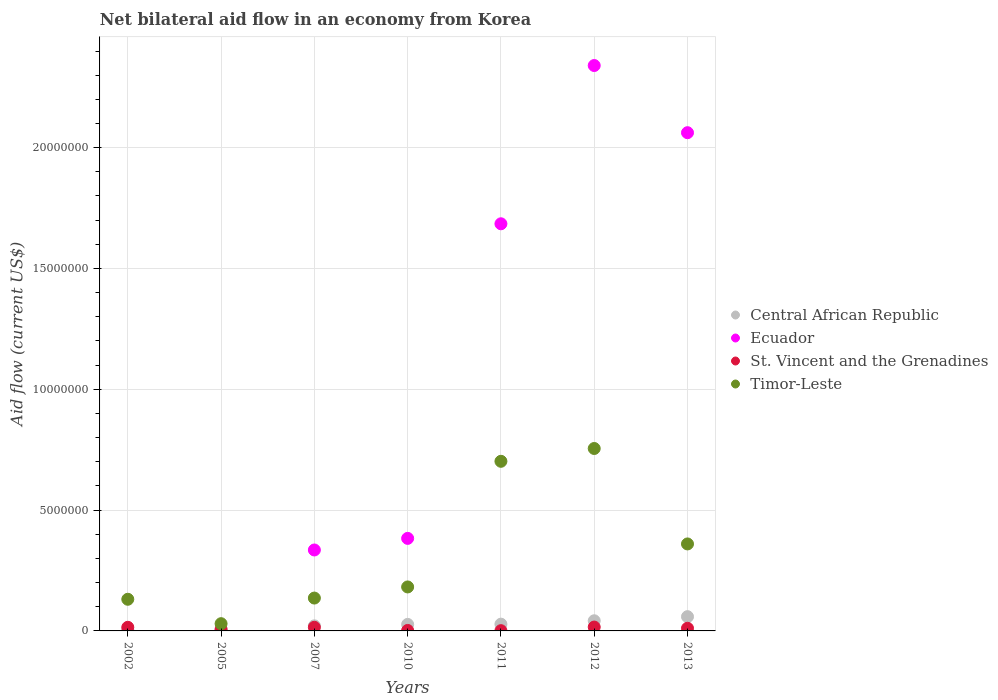How many different coloured dotlines are there?
Offer a terse response. 4. Is the number of dotlines equal to the number of legend labels?
Make the answer very short. No. Across all years, what is the maximum net bilateral aid flow in Ecuador?
Offer a very short reply. 2.34e+07. Across all years, what is the minimum net bilateral aid flow in Timor-Leste?
Ensure brevity in your answer.  3.00e+05. What is the total net bilateral aid flow in Ecuador in the graph?
Your answer should be compact. 6.80e+07. What is the difference between the net bilateral aid flow in Central African Republic in 2005 and that in 2013?
Offer a terse response. -5.20e+05. What is the difference between the net bilateral aid flow in Central African Republic in 2013 and the net bilateral aid flow in St. Vincent and the Grenadines in 2012?
Provide a short and direct response. 4.30e+05. What is the average net bilateral aid flow in Timor-Leste per year?
Your response must be concise. 3.28e+06. In the year 2010, what is the difference between the net bilateral aid flow in Central African Republic and net bilateral aid flow in Timor-Leste?
Your response must be concise. -1.55e+06. What is the ratio of the net bilateral aid flow in Central African Republic in 2005 to that in 2011?
Your answer should be very brief. 0.25. Is the difference between the net bilateral aid flow in Central African Republic in 2007 and 2012 greater than the difference between the net bilateral aid flow in Timor-Leste in 2007 and 2012?
Provide a short and direct response. Yes. What is the difference between the highest and the second highest net bilateral aid flow in Timor-Leste?
Offer a very short reply. 5.30e+05. What is the difference between the highest and the lowest net bilateral aid flow in Central African Republic?
Offer a very short reply. 5.40e+05. Does the net bilateral aid flow in St. Vincent and the Grenadines monotonically increase over the years?
Your answer should be very brief. No. Is the net bilateral aid flow in Central African Republic strictly greater than the net bilateral aid flow in St. Vincent and the Grenadines over the years?
Offer a very short reply. No. Is the net bilateral aid flow in Ecuador strictly less than the net bilateral aid flow in St. Vincent and the Grenadines over the years?
Give a very brief answer. No. How many years are there in the graph?
Provide a short and direct response. 7. Does the graph contain grids?
Offer a very short reply. Yes. What is the title of the graph?
Provide a succinct answer. Net bilateral aid flow in an economy from Korea. Does "Hungary" appear as one of the legend labels in the graph?
Keep it short and to the point. No. What is the label or title of the X-axis?
Your answer should be compact. Years. What is the Aid flow (current US$) of Central African Republic in 2002?
Your answer should be compact. 5.00e+04. What is the Aid flow (current US$) of Ecuador in 2002?
Provide a succinct answer. 0. What is the Aid flow (current US$) in St. Vincent and the Grenadines in 2002?
Offer a very short reply. 1.50e+05. What is the Aid flow (current US$) of Timor-Leste in 2002?
Give a very brief answer. 1.31e+06. What is the Aid flow (current US$) of Central African Republic in 2005?
Your answer should be compact. 7.00e+04. What is the Aid flow (current US$) in St. Vincent and the Grenadines in 2005?
Offer a terse response. 6.00e+04. What is the Aid flow (current US$) of Timor-Leste in 2005?
Offer a terse response. 3.00e+05. What is the Aid flow (current US$) of Ecuador in 2007?
Give a very brief answer. 3.35e+06. What is the Aid flow (current US$) in St. Vincent and the Grenadines in 2007?
Keep it short and to the point. 1.50e+05. What is the Aid flow (current US$) of Timor-Leste in 2007?
Make the answer very short. 1.36e+06. What is the Aid flow (current US$) of Central African Republic in 2010?
Offer a terse response. 2.70e+05. What is the Aid flow (current US$) of Ecuador in 2010?
Provide a short and direct response. 3.83e+06. What is the Aid flow (current US$) in Timor-Leste in 2010?
Your answer should be compact. 1.82e+06. What is the Aid flow (current US$) in Ecuador in 2011?
Ensure brevity in your answer.  1.68e+07. What is the Aid flow (current US$) in Timor-Leste in 2011?
Give a very brief answer. 7.02e+06. What is the Aid flow (current US$) of Central African Republic in 2012?
Provide a succinct answer. 4.20e+05. What is the Aid flow (current US$) of Ecuador in 2012?
Offer a very short reply. 2.34e+07. What is the Aid flow (current US$) in Timor-Leste in 2012?
Provide a succinct answer. 7.55e+06. What is the Aid flow (current US$) in Central African Republic in 2013?
Provide a short and direct response. 5.90e+05. What is the Aid flow (current US$) in Ecuador in 2013?
Offer a very short reply. 2.06e+07. What is the Aid flow (current US$) of Timor-Leste in 2013?
Offer a very short reply. 3.60e+06. Across all years, what is the maximum Aid flow (current US$) in Central African Republic?
Ensure brevity in your answer.  5.90e+05. Across all years, what is the maximum Aid flow (current US$) of Ecuador?
Your response must be concise. 2.34e+07. Across all years, what is the maximum Aid flow (current US$) of Timor-Leste?
Your answer should be very brief. 7.55e+06. Across all years, what is the minimum Aid flow (current US$) of Ecuador?
Give a very brief answer. 0. Across all years, what is the minimum Aid flow (current US$) of St. Vincent and the Grenadines?
Provide a succinct answer. 10000. Across all years, what is the minimum Aid flow (current US$) of Timor-Leste?
Your response must be concise. 3.00e+05. What is the total Aid flow (current US$) of Central African Republic in the graph?
Keep it short and to the point. 1.89e+06. What is the total Aid flow (current US$) in Ecuador in the graph?
Your response must be concise. 6.80e+07. What is the total Aid flow (current US$) of St. Vincent and the Grenadines in the graph?
Keep it short and to the point. 6.60e+05. What is the total Aid flow (current US$) in Timor-Leste in the graph?
Offer a very short reply. 2.30e+07. What is the difference between the Aid flow (current US$) in Central African Republic in 2002 and that in 2005?
Your response must be concise. -2.00e+04. What is the difference between the Aid flow (current US$) of Timor-Leste in 2002 and that in 2005?
Ensure brevity in your answer.  1.01e+06. What is the difference between the Aid flow (current US$) in Central African Republic in 2002 and that in 2007?
Keep it short and to the point. -1.60e+05. What is the difference between the Aid flow (current US$) of Central African Republic in 2002 and that in 2010?
Your answer should be compact. -2.20e+05. What is the difference between the Aid flow (current US$) of St. Vincent and the Grenadines in 2002 and that in 2010?
Your response must be concise. 1.30e+05. What is the difference between the Aid flow (current US$) in Timor-Leste in 2002 and that in 2010?
Offer a terse response. -5.10e+05. What is the difference between the Aid flow (current US$) in Timor-Leste in 2002 and that in 2011?
Provide a short and direct response. -5.71e+06. What is the difference between the Aid flow (current US$) in Central African Republic in 2002 and that in 2012?
Keep it short and to the point. -3.70e+05. What is the difference between the Aid flow (current US$) in Timor-Leste in 2002 and that in 2012?
Give a very brief answer. -6.24e+06. What is the difference between the Aid flow (current US$) of Central African Republic in 2002 and that in 2013?
Your answer should be very brief. -5.40e+05. What is the difference between the Aid flow (current US$) of Timor-Leste in 2002 and that in 2013?
Make the answer very short. -2.29e+06. What is the difference between the Aid flow (current US$) in St. Vincent and the Grenadines in 2005 and that in 2007?
Your answer should be very brief. -9.00e+04. What is the difference between the Aid flow (current US$) in Timor-Leste in 2005 and that in 2007?
Your answer should be very brief. -1.06e+06. What is the difference between the Aid flow (current US$) in St. Vincent and the Grenadines in 2005 and that in 2010?
Your answer should be compact. 4.00e+04. What is the difference between the Aid flow (current US$) of Timor-Leste in 2005 and that in 2010?
Your response must be concise. -1.52e+06. What is the difference between the Aid flow (current US$) in Central African Republic in 2005 and that in 2011?
Your answer should be very brief. -2.10e+05. What is the difference between the Aid flow (current US$) of Timor-Leste in 2005 and that in 2011?
Your answer should be very brief. -6.72e+06. What is the difference between the Aid flow (current US$) of Central African Republic in 2005 and that in 2012?
Your answer should be very brief. -3.50e+05. What is the difference between the Aid flow (current US$) in St. Vincent and the Grenadines in 2005 and that in 2012?
Your answer should be compact. -1.00e+05. What is the difference between the Aid flow (current US$) of Timor-Leste in 2005 and that in 2012?
Make the answer very short. -7.25e+06. What is the difference between the Aid flow (current US$) of Central African Republic in 2005 and that in 2013?
Offer a terse response. -5.20e+05. What is the difference between the Aid flow (current US$) in St. Vincent and the Grenadines in 2005 and that in 2013?
Make the answer very short. -5.00e+04. What is the difference between the Aid flow (current US$) in Timor-Leste in 2005 and that in 2013?
Give a very brief answer. -3.30e+06. What is the difference between the Aid flow (current US$) of Ecuador in 2007 and that in 2010?
Keep it short and to the point. -4.80e+05. What is the difference between the Aid flow (current US$) in St. Vincent and the Grenadines in 2007 and that in 2010?
Give a very brief answer. 1.30e+05. What is the difference between the Aid flow (current US$) in Timor-Leste in 2007 and that in 2010?
Give a very brief answer. -4.60e+05. What is the difference between the Aid flow (current US$) in Central African Republic in 2007 and that in 2011?
Keep it short and to the point. -7.00e+04. What is the difference between the Aid flow (current US$) of Ecuador in 2007 and that in 2011?
Keep it short and to the point. -1.35e+07. What is the difference between the Aid flow (current US$) in Timor-Leste in 2007 and that in 2011?
Your answer should be compact. -5.66e+06. What is the difference between the Aid flow (current US$) in Ecuador in 2007 and that in 2012?
Ensure brevity in your answer.  -2.00e+07. What is the difference between the Aid flow (current US$) in Timor-Leste in 2007 and that in 2012?
Your answer should be very brief. -6.19e+06. What is the difference between the Aid flow (current US$) in Central African Republic in 2007 and that in 2013?
Give a very brief answer. -3.80e+05. What is the difference between the Aid flow (current US$) of Ecuador in 2007 and that in 2013?
Offer a terse response. -1.73e+07. What is the difference between the Aid flow (current US$) of St. Vincent and the Grenadines in 2007 and that in 2013?
Offer a terse response. 4.00e+04. What is the difference between the Aid flow (current US$) of Timor-Leste in 2007 and that in 2013?
Keep it short and to the point. -2.24e+06. What is the difference between the Aid flow (current US$) of Central African Republic in 2010 and that in 2011?
Offer a terse response. -10000. What is the difference between the Aid flow (current US$) of Ecuador in 2010 and that in 2011?
Provide a succinct answer. -1.30e+07. What is the difference between the Aid flow (current US$) of Timor-Leste in 2010 and that in 2011?
Offer a very short reply. -5.20e+06. What is the difference between the Aid flow (current US$) in Ecuador in 2010 and that in 2012?
Your response must be concise. -1.96e+07. What is the difference between the Aid flow (current US$) of St. Vincent and the Grenadines in 2010 and that in 2012?
Provide a succinct answer. -1.40e+05. What is the difference between the Aid flow (current US$) of Timor-Leste in 2010 and that in 2012?
Offer a terse response. -5.73e+06. What is the difference between the Aid flow (current US$) in Central African Republic in 2010 and that in 2013?
Ensure brevity in your answer.  -3.20e+05. What is the difference between the Aid flow (current US$) in Ecuador in 2010 and that in 2013?
Provide a short and direct response. -1.68e+07. What is the difference between the Aid flow (current US$) of St. Vincent and the Grenadines in 2010 and that in 2013?
Provide a succinct answer. -9.00e+04. What is the difference between the Aid flow (current US$) of Timor-Leste in 2010 and that in 2013?
Offer a very short reply. -1.78e+06. What is the difference between the Aid flow (current US$) in Ecuador in 2011 and that in 2012?
Your answer should be compact. -6.55e+06. What is the difference between the Aid flow (current US$) in Timor-Leste in 2011 and that in 2012?
Offer a very short reply. -5.30e+05. What is the difference between the Aid flow (current US$) of Central African Republic in 2011 and that in 2013?
Your answer should be very brief. -3.10e+05. What is the difference between the Aid flow (current US$) of Ecuador in 2011 and that in 2013?
Give a very brief answer. -3.77e+06. What is the difference between the Aid flow (current US$) of St. Vincent and the Grenadines in 2011 and that in 2013?
Give a very brief answer. -1.00e+05. What is the difference between the Aid flow (current US$) of Timor-Leste in 2011 and that in 2013?
Your response must be concise. 3.42e+06. What is the difference between the Aid flow (current US$) in Central African Republic in 2012 and that in 2013?
Make the answer very short. -1.70e+05. What is the difference between the Aid flow (current US$) of Ecuador in 2012 and that in 2013?
Offer a terse response. 2.78e+06. What is the difference between the Aid flow (current US$) of Timor-Leste in 2012 and that in 2013?
Your answer should be compact. 3.95e+06. What is the difference between the Aid flow (current US$) of Central African Republic in 2002 and the Aid flow (current US$) of St. Vincent and the Grenadines in 2005?
Your answer should be compact. -10000. What is the difference between the Aid flow (current US$) of Central African Republic in 2002 and the Aid flow (current US$) of Timor-Leste in 2005?
Make the answer very short. -2.50e+05. What is the difference between the Aid flow (current US$) in St. Vincent and the Grenadines in 2002 and the Aid flow (current US$) in Timor-Leste in 2005?
Ensure brevity in your answer.  -1.50e+05. What is the difference between the Aid flow (current US$) of Central African Republic in 2002 and the Aid flow (current US$) of Ecuador in 2007?
Give a very brief answer. -3.30e+06. What is the difference between the Aid flow (current US$) in Central African Republic in 2002 and the Aid flow (current US$) in St. Vincent and the Grenadines in 2007?
Give a very brief answer. -1.00e+05. What is the difference between the Aid flow (current US$) of Central African Republic in 2002 and the Aid flow (current US$) of Timor-Leste in 2007?
Offer a very short reply. -1.31e+06. What is the difference between the Aid flow (current US$) in St. Vincent and the Grenadines in 2002 and the Aid flow (current US$) in Timor-Leste in 2007?
Your answer should be compact. -1.21e+06. What is the difference between the Aid flow (current US$) in Central African Republic in 2002 and the Aid flow (current US$) in Ecuador in 2010?
Give a very brief answer. -3.78e+06. What is the difference between the Aid flow (current US$) in Central African Republic in 2002 and the Aid flow (current US$) in Timor-Leste in 2010?
Keep it short and to the point. -1.77e+06. What is the difference between the Aid flow (current US$) of St. Vincent and the Grenadines in 2002 and the Aid flow (current US$) of Timor-Leste in 2010?
Give a very brief answer. -1.67e+06. What is the difference between the Aid flow (current US$) of Central African Republic in 2002 and the Aid flow (current US$) of Ecuador in 2011?
Your answer should be very brief. -1.68e+07. What is the difference between the Aid flow (current US$) of Central African Republic in 2002 and the Aid flow (current US$) of St. Vincent and the Grenadines in 2011?
Offer a very short reply. 4.00e+04. What is the difference between the Aid flow (current US$) of Central African Republic in 2002 and the Aid flow (current US$) of Timor-Leste in 2011?
Your answer should be compact. -6.97e+06. What is the difference between the Aid flow (current US$) in St. Vincent and the Grenadines in 2002 and the Aid flow (current US$) in Timor-Leste in 2011?
Provide a succinct answer. -6.87e+06. What is the difference between the Aid flow (current US$) of Central African Republic in 2002 and the Aid flow (current US$) of Ecuador in 2012?
Offer a very short reply. -2.34e+07. What is the difference between the Aid flow (current US$) in Central African Republic in 2002 and the Aid flow (current US$) in St. Vincent and the Grenadines in 2012?
Keep it short and to the point. -1.10e+05. What is the difference between the Aid flow (current US$) in Central African Republic in 2002 and the Aid flow (current US$) in Timor-Leste in 2012?
Provide a short and direct response. -7.50e+06. What is the difference between the Aid flow (current US$) of St. Vincent and the Grenadines in 2002 and the Aid flow (current US$) of Timor-Leste in 2012?
Your response must be concise. -7.40e+06. What is the difference between the Aid flow (current US$) in Central African Republic in 2002 and the Aid flow (current US$) in Ecuador in 2013?
Provide a succinct answer. -2.06e+07. What is the difference between the Aid flow (current US$) in Central African Republic in 2002 and the Aid flow (current US$) in Timor-Leste in 2013?
Offer a very short reply. -3.55e+06. What is the difference between the Aid flow (current US$) of St. Vincent and the Grenadines in 2002 and the Aid flow (current US$) of Timor-Leste in 2013?
Your answer should be very brief. -3.45e+06. What is the difference between the Aid flow (current US$) in Central African Republic in 2005 and the Aid flow (current US$) in Ecuador in 2007?
Offer a terse response. -3.28e+06. What is the difference between the Aid flow (current US$) in Central African Republic in 2005 and the Aid flow (current US$) in St. Vincent and the Grenadines in 2007?
Give a very brief answer. -8.00e+04. What is the difference between the Aid flow (current US$) of Central African Republic in 2005 and the Aid flow (current US$) of Timor-Leste in 2007?
Keep it short and to the point. -1.29e+06. What is the difference between the Aid flow (current US$) in St. Vincent and the Grenadines in 2005 and the Aid flow (current US$) in Timor-Leste in 2007?
Provide a short and direct response. -1.30e+06. What is the difference between the Aid flow (current US$) in Central African Republic in 2005 and the Aid flow (current US$) in Ecuador in 2010?
Make the answer very short. -3.76e+06. What is the difference between the Aid flow (current US$) in Central African Republic in 2005 and the Aid flow (current US$) in St. Vincent and the Grenadines in 2010?
Ensure brevity in your answer.  5.00e+04. What is the difference between the Aid flow (current US$) of Central African Republic in 2005 and the Aid flow (current US$) of Timor-Leste in 2010?
Make the answer very short. -1.75e+06. What is the difference between the Aid flow (current US$) in St. Vincent and the Grenadines in 2005 and the Aid flow (current US$) in Timor-Leste in 2010?
Provide a short and direct response. -1.76e+06. What is the difference between the Aid flow (current US$) in Central African Republic in 2005 and the Aid flow (current US$) in Ecuador in 2011?
Your answer should be compact. -1.68e+07. What is the difference between the Aid flow (current US$) of Central African Republic in 2005 and the Aid flow (current US$) of St. Vincent and the Grenadines in 2011?
Keep it short and to the point. 6.00e+04. What is the difference between the Aid flow (current US$) in Central African Republic in 2005 and the Aid flow (current US$) in Timor-Leste in 2011?
Your answer should be very brief. -6.95e+06. What is the difference between the Aid flow (current US$) in St. Vincent and the Grenadines in 2005 and the Aid flow (current US$) in Timor-Leste in 2011?
Your response must be concise. -6.96e+06. What is the difference between the Aid flow (current US$) of Central African Republic in 2005 and the Aid flow (current US$) of Ecuador in 2012?
Your answer should be very brief. -2.33e+07. What is the difference between the Aid flow (current US$) of Central African Republic in 2005 and the Aid flow (current US$) of St. Vincent and the Grenadines in 2012?
Your answer should be very brief. -9.00e+04. What is the difference between the Aid flow (current US$) of Central African Republic in 2005 and the Aid flow (current US$) of Timor-Leste in 2012?
Ensure brevity in your answer.  -7.48e+06. What is the difference between the Aid flow (current US$) of St. Vincent and the Grenadines in 2005 and the Aid flow (current US$) of Timor-Leste in 2012?
Offer a terse response. -7.49e+06. What is the difference between the Aid flow (current US$) of Central African Republic in 2005 and the Aid flow (current US$) of Ecuador in 2013?
Provide a succinct answer. -2.06e+07. What is the difference between the Aid flow (current US$) of Central African Republic in 2005 and the Aid flow (current US$) of Timor-Leste in 2013?
Give a very brief answer. -3.53e+06. What is the difference between the Aid flow (current US$) in St. Vincent and the Grenadines in 2005 and the Aid flow (current US$) in Timor-Leste in 2013?
Offer a very short reply. -3.54e+06. What is the difference between the Aid flow (current US$) of Central African Republic in 2007 and the Aid flow (current US$) of Ecuador in 2010?
Offer a terse response. -3.62e+06. What is the difference between the Aid flow (current US$) of Central African Republic in 2007 and the Aid flow (current US$) of Timor-Leste in 2010?
Your answer should be compact. -1.61e+06. What is the difference between the Aid flow (current US$) in Ecuador in 2007 and the Aid flow (current US$) in St. Vincent and the Grenadines in 2010?
Ensure brevity in your answer.  3.33e+06. What is the difference between the Aid flow (current US$) in Ecuador in 2007 and the Aid flow (current US$) in Timor-Leste in 2010?
Provide a succinct answer. 1.53e+06. What is the difference between the Aid flow (current US$) in St. Vincent and the Grenadines in 2007 and the Aid flow (current US$) in Timor-Leste in 2010?
Keep it short and to the point. -1.67e+06. What is the difference between the Aid flow (current US$) of Central African Republic in 2007 and the Aid flow (current US$) of Ecuador in 2011?
Provide a short and direct response. -1.66e+07. What is the difference between the Aid flow (current US$) in Central African Republic in 2007 and the Aid flow (current US$) in Timor-Leste in 2011?
Make the answer very short. -6.81e+06. What is the difference between the Aid flow (current US$) in Ecuador in 2007 and the Aid flow (current US$) in St. Vincent and the Grenadines in 2011?
Offer a terse response. 3.34e+06. What is the difference between the Aid flow (current US$) of Ecuador in 2007 and the Aid flow (current US$) of Timor-Leste in 2011?
Provide a succinct answer. -3.67e+06. What is the difference between the Aid flow (current US$) in St. Vincent and the Grenadines in 2007 and the Aid flow (current US$) in Timor-Leste in 2011?
Keep it short and to the point. -6.87e+06. What is the difference between the Aid flow (current US$) in Central African Republic in 2007 and the Aid flow (current US$) in Ecuador in 2012?
Offer a terse response. -2.32e+07. What is the difference between the Aid flow (current US$) of Central African Republic in 2007 and the Aid flow (current US$) of Timor-Leste in 2012?
Offer a terse response. -7.34e+06. What is the difference between the Aid flow (current US$) in Ecuador in 2007 and the Aid flow (current US$) in St. Vincent and the Grenadines in 2012?
Provide a succinct answer. 3.19e+06. What is the difference between the Aid flow (current US$) of Ecuador in 2007 and the Aid flow (current US$) of Timor-Leste in 2012?
Your answer should be very brief. -4.20e+06. What is the difference between the Aid flow (current US$) in St. Vincent and the Grenadines in 2007 and the Aid flow (current US$) in Timor-Leste in 2012?
Keep it short and to the point. -7.40e+06. What is the difference between the Aid flow (current US$) in Central African Republic in 2007 and the Aid flow (current US$) in Ecuador in 2013?
Your answer should be very brief. -2.04e+07. What is the difference between the Aid flow (current US$) of Central African Republic in 2007 and the Aid flow (current US$) of St. Vincent and the Grenadines in 2013?
Make the answer very short. 1.00e+05. What is the difference between the Aid flow (current US$) in Central African Republic in 2007 and the Aid flow (current US$) in Timor-Leste in 2013?
Provide a short and direct response. -3.39e+06. What is the difference between the Aid flow (current US$) of Ecuador in 2007 and the Aid flow (current US$) of St. Vincent and the Grenadines in 2013?
Keep it short and to the point. 3.24e+06. What is the difference between the Aid flow (current US$) of St. Vincent and the Grenadines in 2007 and the Aid flow (current US$) of Timor-Leste in 2013?
Provide a short and direct response. -3.45e+06. What is the difference between the Aid flow (current US$) of Central African Republic in 2010 and the Aid flow (current US$) of Ecuador in 2011?
Give a very brief answer. -1.66e+07. What is the difference between the Aid flow (current US$) of Central African Republic in 2010 and the Aid flow (current US$) of St. Vincent and the Grenadines in 2011?
Offer a very short reply. 2.60e+05. What is the difference between the Aid flow (current US$) in Central African Republic in 2010 and the Aid flow (current US$) in Timor-Leste in 2011?
Your answer should be very brief. -6.75e+06. What is the difference between the Aid flow (current US$) of Ecuador in 2010 and the Aid flow (current US$) of St. Vincent and the Grenadines in 2011?
Ensure brevity in your answer.  3.82e+06. What is the difference between the Aid flow (current US$) in Ecuador in 2010 and the Aid flow (current US$) in Timor-Leste in 2011?
Your answer should be very brief. -3.19e+06. What is the difference between the Aid flow (current US$) of St. Vincent and the Grenadines in 2010 and the Aid flow (current US$) of Timor-Leste in 2011?
Your answer should be compact. -7.00e+06. What is the difference between the Aid flow (current US$) of Central African Republic in 2010 and the Aid flow (current US$) of Ecuador in 2012?
Provide a short and direct response. -2.31e+07. What is the difference between the Aid flow (current US$) in Central African Republic in 2010 and the Aid flow (current US$) in Timor-Leste in 2012?
Your answer should be compact. -7.28e+06. What is the difference between the Aid flow (current US$) in Ecuador in 2010 and the Aid flow (current US$) in St. Vincent and the Grenadines in 2012?
Provide a short and direct response. 3.67e+06. What is the difference between the Aid flow (current US$) in Ecuador in 2010 and the Aid flow (current US$) in Timor-Leste in 2012?
Offer a very short reply. -3.72e+06. What is the difference between the Aid flow (current US$) in St. Vincent and the Grenadines in 2010 and the Aid flow (current US$) in Timor-Leste in 2012?
Provide a succinct answer. -7.53e+06. What is the difference between the Aid flow (current US$) of Central African Republic in 2010 and the Aid flow (current US$) of Ecuador in 2013?
Offer a terse response. -2.04e+07. What is the difference between the Aid flow (current US$) of Central African Republic in 2010 and the Aid flow (current US$) of St. Vincent and the Grenadines in 2013?
Your response must be concise. 1.60e+05. What is the difference between the Aid flow (current US$) of Central African Republic in 2010 and the Aid flow (current US$) of Timor-Leste in 2013?
Give a very brief answer. -3.33e+06. What is the difference between the Aid flow (current US$) in Ecuador in 2010 and the Aid flow (current US$) in St. Vincent and the Grenadines in 2013?
Ensure brevity in your answer.  3.72e+06. What is the difference between the Aid flow (current US$) in St. Vincent and the Grenadines in 2010 and the Aid flow (current US$) in Timor-Leste in 2013?
Offer a very short reply. -3.58e+06. What is the difference between the Aid flow (current US$) in Central African Republic in 2011 and the Aid flow (current US$) in Ecuador in 2012?
Ensure brevity in your answer.  -2.31e+07. What is the difference between the Aid flow (current US$) in Central African Republic in 2011 and the Aid flow (current US$) in St. Vincent and the Grenadines in 2012?
Provide a short and direct response. 1.20e+05. What is the difference between the Aid flow (current US$) in Central African Republic in 2011 and the Aid flow (current US$) in Timor-Leste in 2012?
Your answer should be very brief. -7.27e+06. What is the difference between the Aid flow (current US$) in Ecuador in 2011 and the Aid flow (current US$) in St. Vincent and the Grenadines in 2012?
Give a very brief answer. 1.67e+07. What is the difference between the Aid flow (current US$) in Ecuador in 2011 and the Aid flow (current US$) in Timor-Leste in 2012?
Your answer should be very brief. 9.30e+06. What is the difference between the Aid flow (current US$) of St. Vincent and the Grenadines in 2011 and the Aid flow (current US$) of Timor-Leste in 2012?
Provide a succinct answer. -7.54e+06. What is the difference between the Aid flow (current US$) of Central African Republic in 2011 and the Aid flow (current US$) of Ecuador in 2013?
Ensure brevity in your answer.  -2.03e+07. What is the difference between the Aid flow (current US$) in Central African Republic in 2011 and the Aid flow (current US$) in St. Vincent and the Grenadines in 2013?
Provide a short and direct response. 1.70e+05. What is the difference between the Aid flow (current US$) of Central African Republic in 2011 and the Aid flow (current US$) of Timor-Leste in 2013?
Your answer should be compact. -3.32e+06. What is the difference between the Aid flow (current US$) of Ecuador in 2011 and the Aid flow (current US$) of St. Vincent and the Grenadines in 2013?
Make the answer very short. 1.67e+07. What is the difference between the Aid flow (current US$) in Ecuador in 2011 and the Aid flow (current US$) in Timor-Leste in 2013?
Keep it short and to the point. 1.32e+07. What is the difference between the Aid flow (current US$) in St. Vincent and the Grenadines in 2011 and the Aid flow (current US$) in Timor-Leste in 2013?
Ensure brevity in your answer.  -3.59e+06. What is the difference between the Aid flow (current US$) of Central African Republic in 2012 and the Aid flow (current US$) of Ecuador in 2013?
Ensure brevity in your answer.  -2.02e+07. What is the difference between the Aid flow (current US$) of Central African Republic in 2012 and the Aid flow (current US$) of Timor-Leste in 2013?
Your answer should be very brief. -3.18e+06. What is the difference between the Aid flow (current US$) in Ecuador in 2012 and the Aid flow (current US$) in St. Vincent and the Grenadines in 2013?
Your response must be concise. 2.33e+07. What is the difference between the Aid flow (current US$) in Ecuador in 2012 and the Aid flow (current US$) in Timor-Leste in 2013?
Your response must be concise. 1.98e+07. What is the difference between the Aid flow (current US$) of St. Vincent and the Grenadines in 2012 and the Aid flow (current US$) of Timor-Leste in 2013?
Give a very brief answer. -3.44e+06. What is the average Aid flow (current US$) in Ecuador per year?
Provide a short and direct response. 9.72e+06. What is the average Aid flow (current US$) of St. Vincent and the Grenadines per year?
Ensure brevity in your answer.  9.43e+04. What is the average Aid flow (current US$) of Timor-Leste per year?
Keep it short and to the point. 3.28e+06. In the year 2002, what is the difference between the Aid flow (current US$) in Central African Republic and Aid flow (current US$) in St. Vincent and the Grenadines?
Make the answer very short. -1.00e+05. In the year 2002, what is the difference between the Aid flow (current US$) of Central African Republic and Aid flow (current US$) of Timor-Leste?
Make the answer very short. -1.26e+06. In the year 2002, what is the difference between the Aid flow (current US$) of St. Vincent and the Grenadines and Aid flow (current US$) of Timor-Leste?
Provide a succinct answer. -1.16e+06. In the year 2007, what is the difference between the Aid flow (current US$) in Central African Republic and Aid flow (current US$) in Ecuador?
Offer a terse response. -3.14e+06. In the year 2007, what is the difference between the Aid flow (current US$) of Central African Republic and Aid flow (current US$) of Timor-Leste?
Make the answer very short. -1.15e+06. In the year 2007, what is the difference between the Aid flow (current US$) of Ecuador and Aid flow (current US$) of St. Vincent and the Grenadines?
Your answer should be compact. 3.20e+06. In the year 2007, what is the difference between the Aid flow (current US$) of Ecuador and Aid flow (current US$) of Timor-Leste?
Keep it short and to the point. 1.99e+06. In the year 2007, what is the difference between the Aid flow (current US$) of St. Vincent and the Grenadines and Aid flow (current US$) of Timor-Leste?
Give a very brief answer. -1.21e+06. In the year 2010, what is the difference between the Aid flow (current US$) in Central African Republic and Aid flow (current US$) in Ecuador?
Provide a succinct answer. -3.56e+06. In the year 2010, what is the difference between the Aid flow (current US$) of Central African Republic and Aid flow (current US$) of St. Vincent and the Grenadines?
Your answer should be very brief. 2.50e+05. In the year 2010, what is the difference between the Aid flow (current US$) in Central African Republic and Aid flow (current US$) in Timor-Leste?
Your answer should be very brief. -1.55e+06. In the year 2010, what is the difference between the Aid flow (current US$) of Ecuador and Aid flow (current US$) of St. Vincent and the Grenadines?
Provide a short and direct response. 3.81e+06. In the year 2010, what is the difference between the Aid flow (current US$) of Ecuador and Aid flow (current US$) of Timor-Leste?
Your answer should be compact. 2.01e+06. In the year 2010, what is the difference between the Aid flow (current US$) in St. Vincent and the Grenadines and Aid flow (current US$) in Timor-Leste?
Offer a terse response. -1.80e+06. In the year 2011, what is the difference between the Aid flow (current US$) in Central African Republic and Aid flow (current US$) in Ecuador?
Offer a very short reply. -1.66e+07. In the year 2011, what is the difference between the Aid flow (current US$) of Central African Republic and Aid flow (current US$) of St. Vincent and the Grenadines?
Keep it short and to the point. 2.70e+05. In the year 2011, what is the difference between the Aid flow (current US$) of Central African Republic and Aid flow (current US$) of Timor-Leste?
Give a very brief answer. -6.74e+06. In the year 2011, what is the difference between the Aid flow (current US$) of Ecuador and Aid flow (current US$) of St. Vincent and the Grenadines?
Offer a terse response. 1.68e+07. In the year 2011, what is the difference between the Aid flow (current US$) of Ecuador and Aid flow (current US$) of Timor-Leste?
Ensure brevity in your answer.  9.83e+06. In the year 2011, what is the difference between the Aid flow (current US$) of St. Vincent and the Grenadines and Aid flow (current US$) of Timor-Leste?
Offer a very short reply. -7.01e+06. In the year 2012, what is the difference between the Aid flow (current US$) in Central African Republic and Aid flow (current US$) in Ecuador?
Give a very brief answer. -2.30e+07. In the year 2012, what is the difference between the Aid flow (current US$) of Central African Republic and Aid flow (current US$) of Timor-Leste?
Make the answer very short. -7.13e+06. In the year 2012, what is the difference between the Aid flow (current US$) in Ecuador and Aid flow (current US$) in St. Vincent and the Grenadines?
Your answer should be very brief. 2.32e+07. In the year 2012, what is the difference between the Aid flow (current US$) of Ecuador and Aid flow (current US$) of Timor-Leste?
Your answer should be compact. 1.58e+07. In the year 2012, what is the difference between the Aid flow (current US$) of St. Vincent and the Grenadines and Aid flow (current US$) of Timor-Leste?
Provide a short and direct response. -7.39e+06. In the year 2013, what is the difference between the Aid flow (current US$) in Central African Republic and Aid flow (current US$) in Ecuador?
Keep it short and to the point. -2.00e+07. In the year 2013, what is the difference between the Aid flow (current US$) in Central African Republic and Aid flow (current US$) in St. Vincent and the Grenadines?
Ensure brevity in your answer.  4.80e+05. In the year 2013, what is the difference between the Aid flow (current US$) in Central African Republic and Aid flow (current US$) in Timor-Leste?
Ensure brevity in your answer.  -3.01e+06. In the year 2013, what is the difference between the Aid flow (current US$) in Ecuador and Aid flow (current US$) in St. Vincent and the Grenadines?
Your response must be concise. 2.05e+07. In the year 2013, what is the difference between the Aid flow (current US$) of Ecuador and Aid flow (current US$) of Timor-Leste?
Provide a short and direct response. 1.70e+07. In the year 2013, what is the difference between the Aid flow (current US$) of St. Vincent and the Grenadines and Aid flow (current US$) of Timor-Leste?
Your response must be concise. -3.49e+06. What is the ratio of the Aid flow (current US$) of Central African Republic in 2002 to that in 2005?
Keep it short and to the point. 0.71. What is the ratio of the Aid flow (current US$) in Timor-Leste in 2002 to that in 2005?
Your answer should be compact. 4.37. What is the ratio of the Aid flow (current US$) of Central African Republic in 2002 to that in 2007?
Ensure brevity in your answer.  0.24. What is the ratio of the Aid flow (current US$) in Timor-Leste in 2002 to that in 2007?
Give a very brief answer. 0.96. What is the ratio of the Aid flow (current US$) of Central African Republic in 2002 to that in 2010?
Give a very brief answer. 0.19. What is the ratio of the Aid flow (current US$) in Timor-Leste in 2002 to that in 2010?
Offer a very short reply. 0.72. What is the ratio of the Aid flow (current US$) of Central African Republic in 2002 to that in 2011?
Your response must be concise. 0.18. What is the ratio of the Aid flow (current US$) of St. Vincent and the Grenadines in 2002 to that in 2011?
Ensure brevity in your answer.  15. What is the ratio of the Aid flow (current US$) in Timor-Leste in 2002 to that in 2011?
Give a very brief answer. 0.19. What is the ratio of the Aid flow (current US$) in Central African Republic in 2002 to that in 2012?
Provide a succinct answer. 0.12. What is the ratio of the Aid flow (current US$) of Timor-Leste in 2002 to that in 2012?
Offer a very short reply. 0.17. What is the ratio of the Aid flow (current US$) in Central African Republic in 2002 to that in 2013?
Offer a very short reply. 0.08. What is the ratio of the Aid flow (current US$) of St. Vincent and the Grenadines in 2002 to that in 2013?
Make the answer very short. 1.36. What is the ratio of the Aid flow (current US$) in Timor-Leste in 2002 to that in 2013?
Provide a succinct answer. 0.36. What is the ratio of the Aid flow (current US$) of Central African Republic in 2005 to that in 2007?
Offer a very short reply. 0.33. What is the ratio of the Aid flow (current US$) in St. Vincent and the Grenadines in 2005 to that in 2007?
Ensure brevity in your answer.  0.4. What is the ratio of the Aid flow (current US$) of Timor-Leste in 2005 to that in 2007?
Offer a very short reply. 0.22. What is the ratio of the Aid flow (current US$) in Central African Republic in 2005 to that in 2010?
Ensure brevity in your answer.  0.26. What is the ratio of the Aid flow (current US$) of St. Vincent and the Grenadines in 2005 to that in 2010?
Make the answer very short. 3. What is the ratio of the Aid flow (current US$) in Timor-Leste in 2005 to that in 2010?
Your response must be concise. 0.16. What is the ratio of the Aid flow (current US$) in Central African Republic in 2005 to that in 2011?
Your answer should be very brief. 0.25. What is the ratio of the Aid flow (current US$) in Timor-Leste in 2005 to that in 2011?
Keep it short and to the point. 0.04. What is the ratio of the Aid flow (current US$) in St. Vincent and the Grenadines in 2005 to that in 2012?
Your answer should be compact. 0.38. What is the ratio of the Aid flow (current US$) of Timor-Leste in 2005 to that in 2012?
Your answer should be compact. 0.04. What is the ratio of the Aid flow (current US$) in Central African Republic in 2005 to that in 2013?
Provide a short and direct response. 0.12. What is the ratio of the Aid flow (current US$) of St. Vincent and the Grenadines in 2005 to that in 2013?
Your answer should be compact. 0.55. What is the ratio of the Aid flow (current US$) of Timor-Leste in 2005 to that in 2013?
Your response must be concise. 0.08. What is the ratio of the Aid flow (current US$) in Central African Republic in 2007 to that in 2010?
Give a very brief answer. 0.78. What is the ratio of the Aid flow (current US$) in Ecuador in 2007 to that in 2010?
Offer a terse response. 0.87. What is the ratio of the Aid flow (current US$) in St. Vincent and the Grenadines in 2007 to that in 2010?
Keep it short and to the point. 7.5. What is the ratio of the Aid flow (current US$) in Timor-Leste in 2007 to that in 2010?
Give a very brief answer. 0.75. What is the ratio of the Aid flow (current US$) of Ecuador in 2007 to that in 2011?
Provide a succinct answer. 0.2. What is the ratio of the Aid flow (current US$) in St. Vincent and the Grenadines in 2007 to that in 2011?
Keep it short and to the point. 15. What is the ratio of the Aid flow (current US$) of Timor-Leste in 2007 to that in 2011?
Provide a succinct answer. 0.19. What is the ratio of the Aid flow (current US$) in Central African Republic in 2007 to that in 2012?
Your response must be concise. 0.5. What is the ratio of the Aid flow (current US$) of Ecuador in 2007 to that in 2012?
Your answer should be very brief. 0.14. What is the ratio of the Aid flow (current US$) in Timor-Leste in 2007 to that in 2012?
Provide a succinct answer. 0.18. What is the ratio of the Aid flow (current US$) of Central African Republic in 2007 to that in 2013?
Offer a terse response. 0.36. What is the ratio of the Aid flow (current US$) of Ecuador in 2007 to that in 2013?
Offer a very short reply. 0.16. What is the ratio of the Aid flow (current US$) of St. Vincent and the Grenadines in 2007 to that in 2013?
Your answer should be compact. 1.36. What is the ratio of the Aid flow (current US$) in Timor-Leste in 2007 to that in 2013?
Offer a very short reply. 0.38. What is the ratio of the Aid flow (current US$) of Ecuador in 2010 to that in 2011?
Make the answer very short. 0.23. What is the ratio of the Aid flow (current US$) in Timor-Leste in 2010 to that in 2011?
Ensure brevity in your answer.  0.26. What is the ratio of the Aid flow (current US$) of Central African Republic in 2010 to that in 2012?
Keep it short and to the point. 0.64. What is the ratio of the Aid flow (current US$) of Ecuador in 2010 to that in 2012?
Keep it short and to the point. 0.16. What is the ratio of the Aid flow (current US$) in St. Vincent and the Grenadines in 2010 to that in 2012?
Offer a very short reply. 0.12. What is the ratio of the Aid flow (current US$) of Timor-Leste in 2010 to that in 2012?
Ensure brevity in your answer.  0.24. What is the ratio of the Aid flow (current US$) of Central African Republic in 2010 to that in 2013?
Ensure brevity in your answer.  0.46. What is the ratio of the Aid flow (current US$) in Ecuador in 2010 to that in 2013?
Offer a very short reply. 0.19. What is the ratio of the Aid flow (current US$) in St. Vincent and the Grenadines in 2010 to that in 2013?
Your answer should be very brief. 0.18. What is the ratio of the Aid flow (current US$) in Timor-Leste in 2010 to that in 2013?
Offer a very short reply. 0.51. What is the ratio of the Aid flow (current US$) of Ecuador in 2011 to that in 2012?
Ensure brevity in your answer.  0.72. What is the ratio of the Aid flow (current US$) in St. Vincent and the Grenadines in 2011 to that in 2012?
Ensure brevity in your answer.  0.06. What is the ratio of the Aid flow (current US$) of Timor-Leste in 2011 to that in 2012?
Offer a very short reply. 0.93. What is the ratio of the Aid flow (current US$) in Central African Republic in 2011 to that in 2013?
Offer a very short reply. 0.47. What is the ratio of the Aid flow (current US$) in Ecuador in 2011 to that in 2013?
Make the answer very short. 0.82. What is the ratio of the Aid flow (current US$) in St. Vincent and the Grenadines in 2011 to that in 2013?
Give a very brief answer. 0.09. What is the ratio of the Aid flow (current US$) of Timor-Leste in 2011 to that in 2013?
Provide a short and direct response. 1.95. What is the ratio of the Aid flow (current US$) in Central African Republic in 2012 to that in 2013?
Your answer should be very brief. 0.71. What is the ratio of the Aid flow (current US$) in Ecuador in 2012 to that in 2013?
Make the answer very short. 1.13. What is the ratio of the Aid flow (current US$) in St. Vincent and the Grenadines in 2012 to that in 2013?
Your answer should be compact. 1.45. What is the ratio of the Aid flow (current US$) of Timor-Leste in 2012 to that in 2013?
Offer a very short reply. 2.1. What is the difference between the highest and the second highest Aid flow (current US$) in Ecuador?
Keep it short and to the point. 2.78e+06. What is the difference between the highest and the second highest Aid flow (current US$) of St. Vincent and the Grenadines?
Provide a succinct answer. 10000. What is the difference between the highest and the second highest Aid flow (current US$) in Timor-Leste?
Ensure brevity in your answer.  5.30e+05. What is the difference between the highest and the lowest Aid flow (current US$) in Central African Republic?
Ensure brevity in your answer.  5.40e+05. What is the difference between the highest and the lowest Aid flow (current US$) in Ecuador?
Give a very brief answer. 2.34e+07. What is the difference between the highest and the lowest Aid flow (current US$) in St. Vincent and the Grenadines?
Your answer should be compact. 1.50e+05. What is the difference between the highest and the lowest Aid flow (current US$) of Timor-Leste?
Give a very brief answer. 7.25e+06. 